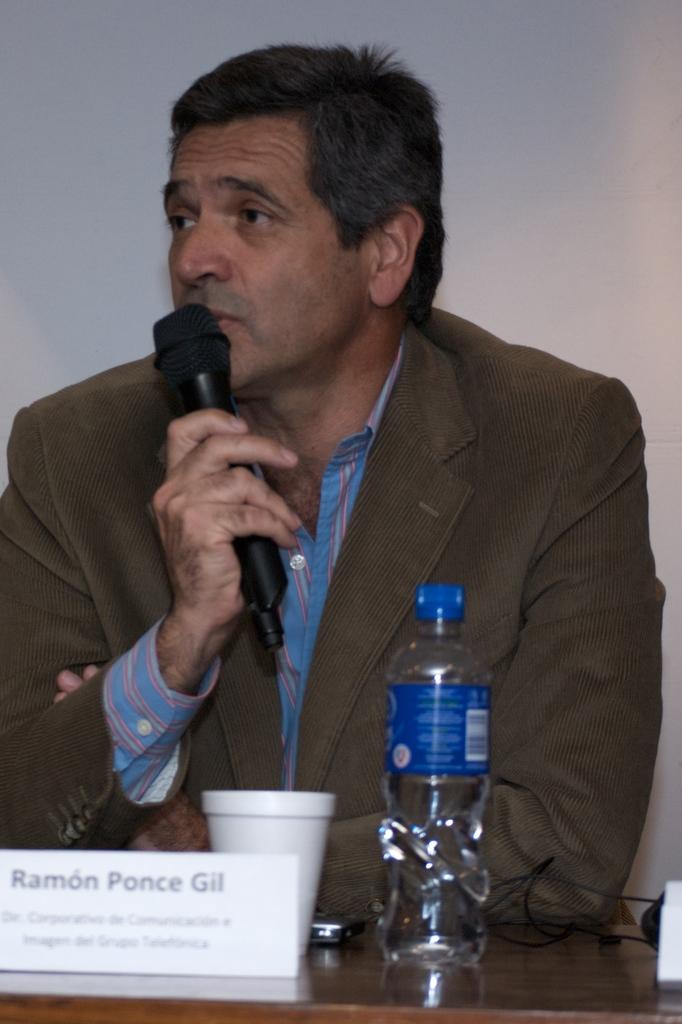What is the main subject of the image? There is a person sitting in the center of the image. What is the person holding in the image? The person is holding a microphone. What is the other main object in the image? There is a table in the image. What can be found on the table? There are objects on the table. How many beds can be seen in the image? There are no beds present in the image. What emotion is the person expressing while holding the crayon in the image? There is no crayon present in the image, and the person's emotions cannot be determined from the image alone. 